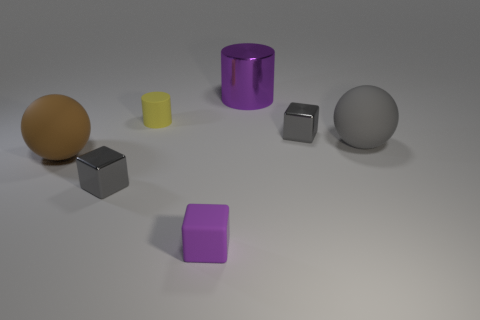Add 1 brown objects. How many objects exist? 8 Subtract all metallic blocks. How many blocks are left? 1 Subtract all gray cubes. How many cubes are left? 1 Subtract all cylinders. How many objects are left? 5 Subtract all brown cylinders. How many purple blocks are left? 1 Subtract 3 blocks. How many blocks are left? 0 Subtract all green spheres. Subtract all blue blocks. How many spheres are left? 2 Subtract all small brown metal spheres. Subtract all brown objects. How many objects are left? 6 Add 5 small blocks. How many small blocks are left? 8 Add 7 large brown matte objects. How many large brown matte objects exist? 8 